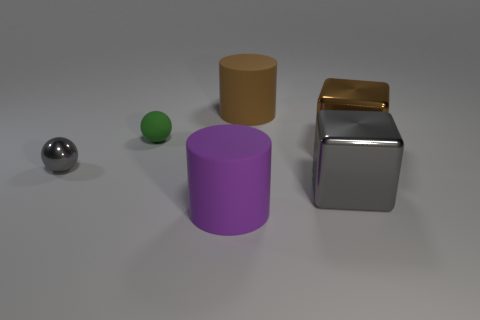Are there any gray metal things in front of the gray metal block?
Offer a terse response. No. What is the material of the large brown cube?
Keep it short and to the point. Metal. The metallic thing that is on the left side of the big gray cube has what shape?
Your answer should be very brief. Sphere. What size is the thing that is the same color as the shiny sphere?
Give a very brief answer. Large. Are there any red balls that have the same size as the purple thing?
Keep it short and to the point. No. Do the sphere in front of the small rubber ball and the green sphere have the same material?
Make the answer very short. No. Are there an equal number of large gray blocks that are behind the tiny green thing and gray metallic objects that are behind the large gray metallic block?
Ensure brevity in your answer.  No. The large thing that is both behind the large gray shiny object and left of the gray metal cube has what shape?
Ensure brevity in your answer.  Cylinder. There is a large purple object; what number of small spheres are in front of it?
Offer a very short reply. 0. What number of other things are there of the same shape as the small green rubber thing?
Ensure brevity in your answer.  1. 